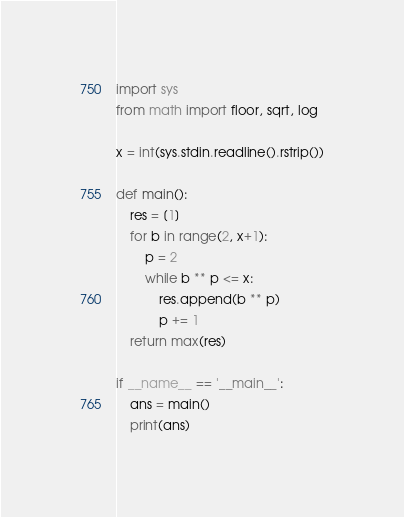Convert code to text. <code><loc_0><loc_0><loc_500><loc_500><_Python_>import sys
from math import floor, sqrt, log

x = int(sys.stdin.readline().rstrip())

def main():
    res = [1]
    for b in range(2, x+1):
        p = 2
        while b ** p <= x:
            res.append(b ** p)
            p += 1
    return max(res)

if __name__ == '__main__':
    ans = main()
    print(ans)</code> 